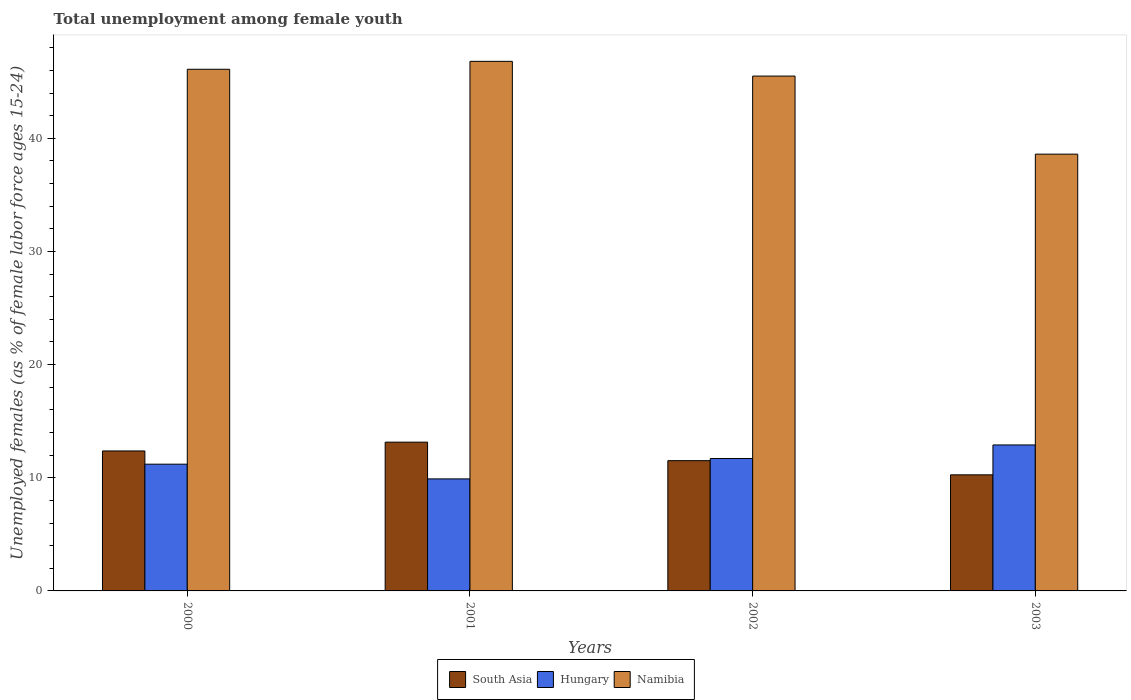How many different coloured bars are there?
Your answer should be compact. 3. How many groups of bars are there?
Keep it short and to the point. 4. Are the number of bars per tick equal to the number of legend labels?
Your response must be concise. Yes. Are the number of bars on each tick of the X-axis equal?
Keep it short and to the point. Yes. How many bars are there on the 4th tick from the left?
Ensure brevity in your answer.  3. How many bars are there on the 3rd tick from the right?
Offer a very short reply. 3. What is the label of the 2nd group of bars from the left?
Offer a very short reply. 2001. What is the percentage of unemployed females in in Hungary in 2002?
Keep it short and to the point. 11.7. Across all years, what is the maximum percentage of unemployed females in in Hungary?
Keep it short and to the point. 12.9. Across all years, what is the minimum percentage of unemployed females in in South Asia?
Your response must be concise. 10.26. What is the total percentage of unemployed females in in Namibia in the graph?
Your answer should be compact. 177. What is the difference between the percentage of unemployed females in in South Asia in 2000 and that in 2003?
Make the answer very short. 2.11. What is the difference between the percentage of unemployed females in in South Asia in 2000 and the percentage of unemployed females in in Namibia in 2002?
Your answer should be compact. -33.13. What is the average percentage of unemployed females in in South Asia per year?
Keep it short and to the point. 11.82. In the year 2001, what is the difference between the percentage of unemployed females in in South Asia and percentage of unemployed females in in Namibia?
Offer a terse response. -33.65. What is the ratio of the percentage of unemployed females in in South Asia in 2000 to that in 2001?
Keep it short and to the point. 0.94. What is the difference between the highest and the second highest percentage of unemployed females in in South Asia?
Provide a succinct answer. 0.78. What is the difference between the highest and the lowest percentage of unemployed females in in South Asia?
Provide a succinct answer. 2.89. Is the sum of the percentage of unemployed females in in Hungary in 2000 and 2002 greater than the maximum percentage of unemployed females in in South Asia across all years?
Keep it short and to the point. Yes. What does the 2nd bar from the left in 2003 represents?
Ensure brevity in your answer.  Hungary. What does the 3rd bar from the right in 2002 represents?
Your answer should be compact. South Asia. Is it the case that in every year, the sum of the percentage of unemployed females in in Hungary and percentage of unemployed females in in Namibia is greater than the percentage of unemployed females in in South Asia?
Make the answer very short. Yes. How many bars are there?
Offer a terse response. 12. Does the graph contain grids?
Keep it short and to the point. No. How many legend labels are there?
Make the answer very short. 3. What is the title of the graph?
Give a very brief answer. Total unemployment among female youth. Does "Nepal" appear as one of the legend labels in the graph?
Provide a succinct answer. No. What is the label or title of the Y-axis?
Keep it short and to the point. Unemployed females (as % of female labor force ages 15-24). What is the Unemployed females (as % of female labor force ages 15-24) in South Asia in 2000?
Your response must be concise. 12.37. What is the Unemployed females (as % of female labor force ages 15-24) of Hungary in 2000?
Provide a succinct answer. 11.2. What is the Unemployed females (as % of female labor force ages 15-24) in Namibia in 2000?
Offer a very short reply. 46.1. What is the Unemployed females (as % of female labor force ages 15-24) in South Asia in 2001?
Your answer should be very brief. 13.15. What is the Unemployed females (as % of female labor force ages 15-24) in Hungary in 2001?
Your answer should be compact. 9.9. What is the Unemployed females (as % of female labor force ages 15-24) of Namibia in 2001?
Your answer should be compact. 46.8. What is the Unemployed females (as % of female labor force ages 15-24) in South Asia in 2002?
Make the answer very short. 11.51. What is the Unemployed females (as % of female labor force ages 15-24) of Hungary in 2002?
Give a very brief answer. 11.7. What is the Unemployed females (as % of female labor force ages 15-24) of Namibia in 2002?
Give a very brief answer. 45.5. What is the Unemployed females (as % of female labor force ages 15-24) in South Asia in 2003?
Your response must be concise. 10.26. What is the Unemployed females (as % of female labor force ages 15-24) of Hungary in 2003?
Your answer should be very brief. 12.9. What is the Unemployed females (as % of female labor force ages 15-24) of Namibia in 2003?
Your response must be concise. 38.6. Across all years, what is the maximum Unemployed females (as % of female labor force ages 15-24) of South Asia?
Your answer should be very brief. 13.15. Across all years, what is the maximum Unemployed females (as % of female labor force ages 15-24) in Hungary?
Your answer should be very brief. 12.9. Across all years, what is the maximum Unemployed females (as % of female labor force ages 15-24) of Namibia?
Provide a short and direct response. 46.8. Across all years, what is the minimum Unemployed females (as % of female labor force ages 15-24) in South Asia?
Your answer should be very brief. 10.26. Across all years, what is the minimum Unemployed females (as % of female labor force ages 15-24) of Hungary?
Provide a short and direct response. 9.9. Across all years, what is the minimum Unemployed females (as % of female labor force ages 15-24) of Namibia?
Keep it short and to the point. 38.6. What is the total Unemployed females (as % of female labor force ages 15-24) in South Asia in the graph?
Your answer should be compact. 47.29. What is the total Unemployed females (as % of female labor force ages 15-24) in Hungary in the graph?
Ensure brevity in your answer.  45.7. What is the total Unemployed females (as % of female labor force ages 15-24) in Namibia in the graph?
Provide a succinct answer. 177. What is the difference between the Unemployed females (as % of female labor force ages 15-24) in South Asia in 2000 and that in 2001?
Your answer should be very brief. -0.78. What is the difference between the Unemployed females (as % of female labor force ages 15-24) in South Asia in 2000 and that in 2002?
Keep it short and to the point. 0.86. What is the difference between the Unemployed females (as % of female labor force ages 15-24) in Hungary in 2000 and that in 2002?
Your answer should be very brief. -0.5. What is the difference between the Unemployed females (as % of female labor force ages 15-24) in Namibia in 2000 and that in 2002?
Your answer should be very brief. 0.6. What is the difference between the Unemployed females (as % of female labor force ages 15-24) in South Asia in 2000 and that in 2003?
Make the answer very short. 2.11. What is the difference between the Unemployed females (as % of female labor force ages 15-24) in Hungary in 2000 and that in 2003?
Offer a very short reply. -1.7. What is the difference between the Unemployed females (as % of female labor force ages 15-24) of South Asia in 2001 and that in 2002?
Make the answer very short. 1.64. What is the difference between the Unemployed females (as % of female labor force ages 15-24) of Hungary in 2001 and that in 2002?
Provide a short and direct response. -1.8. What is the difference between the Unemployed females (as % of female labor force ages 15-24) of South Asia in 2001 and that in 2003?
Ensure brevity in your answer.  2.89. What is the difference between the Unemployed females (as % of female labor force ages 15-24) of South Asia in 2002 and that in 2003?
Offer a very short reply. 1.25. What is the difference between the Unemployed females (as % of female labor force ages 15-24) in Hungary in 2002 and that in 2003?
Offer a very short reply. -1.2. What is the difference between the Unemployed females (as % of female labor force ages 15-24) of Namibia in 2002 and that in 2003?
Offer a very short reply. 6.9. What is the difference between the Unemployed females (as % of female labor force ages 15-24) of South Asia in 2000 and the Unemployed females (as % of female labor force ages 15-24) of Hungary in 2001?
Your answer should be compact. 2.47. What is the difference between the Unemployed females (as % of female labor force ages 15-24) in South Asia in 2000 and the Unemployed females (as % of female labor force ages 15-24) in Namibia in 2001?
Your answer should be compact. -34.43. What is the difference between the Unemployed females (as % of female labor force ages 15-24) in Hungary in 2000 and the Unemployed females (as % of female labor force ages 15-24) in Namibia in 2001?
Give a very brief answer. -35.6. What is the difference between the Unemployed females (as % of female labor force ages 15-24) of South Asia in 2000 and the Unemployed females (as % of female labor force ages 15-24) of Hungary in 2002?
Your answer should be compact. 0.67. What is the difference between the Unemployed females (as % of female labor force ages 15-24) of South Asia in 2000 and the Unemployed females (as % of female labor force ages 15-24) of Namibia in 2002?
Your response must be concise. -33.13. What is the difference between the Unemployed females (as % of female labor force ages 15-24) in Hungary in 2000 and the Unemployed females (as % of female labor force ages 15-24) in Namibia in 2002?
Your answer should be very brief. -34.3. What is the difference between the Unemployed females (as % of female labor force ages 15-24) in South Asia in 2000 and the Unemployed females (as % of female labor force ages 15-24) in Hungary in 2003?
Your answer should be compact. -0.53. What is the difference between the Unemployed females (as % of female labor force ages 15-24) of South Asia in 2000 and the Unemployed females (as % of female labor force ages 15-24) of Namibia in 2003?
Your answer should be very brief. -26.23. What is the difference between the Unemployed females (as % of female labor force ages 15-24) of Hungary in 2000 and the Unemployed females (as % of female labor force ages 15-24) of Namibia in 2003?
Offer a terse response. -27.4. What is the difference between the Unemployed females (as % of female labor force ages 15-24) in South Asia in 2001 and the Unemployed females (as % of female labor force ages 15-24) in Hungary in 2002?
Keep it short and to the point. 1.45. What is the difference between the Unemployed females (as % of female labor force ages 15-24) in South Asia in 2001 and the Unemployed females (as % of female labor force ages 15-24) in Namibia in 2002?
Make the answer very short. -32.35. What is the difference between the Unemployed females (as % of female labor force ages 15-24) in Hungary in 2001 and the Unemployed females (as % of female labor force ages 15-24) in Namibia in 2002?
Provide a short and direct response. -35.6. What is the difference between the Unemployed females (as % of female labor force ages 15-24) of South Asia in 2001 and the Unemployed females (as % of female labor force ages 15-24) of Hungary in 2003?
Your answer should be very brief. 0.25. What is the difference between the Unemployed females (as % of female labor force ages 15-24) of South Asia in 2001 and the Unemployed females (as % of female labor force ages 15-24) of Namibia in 2003?
Offer a very short reply. -25.45. What is the difference between the Unemployed females (as % of female labor force ages 15-24) of Hungary in 2001 and the Unemployed females (as % of female labor force ages 15-24) of Namibia in 2003?
Give a very brief answer. -28.7. What is the difference between the Unemployed females (as % of female labor force ages 15-24) of South Asia in 2002 and the Unemployed females (as % of female labor force ages 15-24) of Hungary in 2003?
Your answer should be compact. -1.39. What is the difference between the Unemployed females (as % of female labor force ages 15-24) in South Asia in 2002 and the Unemployed females (as % of female labor force ages 15-24) in Namibia in 2003?
Give a very brief answer. -27.09. What is the difference between the Unemployed females (as % of female labor force ages 15-24) in Hungary in 2002 and the Unemployed females (as % of female labor force ages 15-24) in Namibia in 2003?
Offer a very short reply. -26.9. What is the average Unemployed females (as % of female labor force ages 15-24) in South Asia per year?
Your answer should be very brief. 11.82. What is the average Unemployed females (as % of female labor force ages 15-24) in Hungary per year?
Make the answer very short. 11.43. What is the average Unemployed females (as % of female labor force ages 15-24) in Namibia per year?
Offer a very short reply. 44.25. In the year 2000, what is the difference between the Unemployed females (as % of female labor force ages 15-24) in South Asia and Unemployed females (as % of female labor force ages 15-24) in Hungary?
Make the answer very short. 1.17. In the year 2000, what is the difference between the Unemployed females (as % of female labor force ages 15-24) in South Asia and Unemployed females (as % of female labor force ages 15-24) in Namibia?
Offer a very short reply. -33.73. In the year 2000, what is the difference between the Unemployed females (as % of female labor force ages 15-24) in Hungary and Unemployed females (as % of female labor force ages 15-24) in Namibia?
Give a very brief answer. -34.9. In the year 2001, what is the difference between the Unemployed females (as % of female labor force ages 15-24) of South Asia and Unemployed females (as % of female labor force ages 15-24) of Hungary?
Ensure brevity in your answer.  3.25. In the year 2001, what is the difference between the Unemployed females (as % of female labor force ages 15-24) of South Asia and Unemployed females (as % of female labor force ages 15-24) of Namibia?
Keep it short and to the point. -33.65. In the year 2001, what is the difference between the Unemployed females (as % of female labor force ages 15-24) of Hungary and Unemployed females (as % of female labor force ages 15-24) of Namibia?
Offer a terse response. -36.9. In the year 2002, what is the difference between the Unemployed females (as % of female labor force ages 15-24) in South Asia and Unemployed females (as % of female labor force ages 15-24) in Hungary?
Ensure brevity in your answer.  -0.19. In the year 2002, what is the difference between the Unemployed females (as % of female labor force ages 15-24) in South Asia and Unemployed females (as % of female labor force ages 15-24) in Namibia?
Ensure brevity in your answer.  -33.99. In the year 2002, what is the difference between the Unemployed females (as % of female labor force ages 15-24) in Hungary and Unemployed females (as % of female labor force ages 15-24) in Namibia?
Keep it short and to the point. -33.8. In the year 2003, what is the difference between the Unemployed females (as % of female labor force ages 15-24) in South Asia and Unemployed females (as % of female labor force ages 15-24) in Hungary?
Give a very brief answer. -2.64. In the year 2003, what is the difference between the Unemployed females (as % of female labor force ages 15-24) of South Asia and Unemployed females (as % of female labor force ages 15-24) of Namibia?
Offer a terse response. -28.34. In the year 2003, what is the difference between the Unemployed females (as % of female labor force ages 15-24) in Hungary and Unemployed females (as % of female labor force ages 15-24) in Namibia?
Provide a succinct answer. -25.7. What is the ratio of the Unemployed females (as % of female labor force ages 15-24) in South Asia in 2000 to that in 2001?
Offer a terse response. 0.94. What is the ratio of the Unemployed females (as % of female labor force ages 15-24) of Hungary in 2000 to that in 2001?
Your answer should be compact. 1.13. What is the ratio of the Unemployed females (as % of female labor force ages 15-24) of South Asia in 2000 to that in 2002?
Make the answer very short. 1.07. What is the ratio of the Unemployed females (as % of female labor force ages 15-24) in Hungary in 2000 to that in 2002?
Make the answer very short. 0.96. What is the ratio of the Unemployed females (as % of female labor force ages 15-24) of Namibia in 2000 to that in 2002?
Ensure brevity in your answer.  1.01. What is the ratio of the Unemployed females (as % of female labor force ages 15-24) of South Asia in 2000 to that in 2003?
Offer a terse response. 1.21. What is the ratio of the Unemployed females (as % of female labor force ages 15-24) of Hungary in 2000 to that in 2003?
Keep it short and to the point. 0.87. What is the ratio of the Unemployed females (as % of female labor force ages 15-24) in Namibia in 2000 to that in 2003?
Keep it short and to the point. 1.19. What is the ratio of the Unemployed females (as % of female labor force ages 15-24) of South Asia in 2001 to that in 2002?
Ensure brevity in your answer.  1.14. What is the ratio of the Unemployed females (as % of female labor force ages 15-24) of Hungary in 2001 to that in 2002?
Provide a short and direct response. 0.85. What is the ratio of the Unemployed females (as % of female labor force ages 15-24) in Namibia in 2001 to that in 2002?
Provide a short and direct response. 1.03. What is the ratio of the Unemployed females (as % of female labor force ages 15-24) of South Asia in 2001 to that in 2003?
Offer a terse response. 1.28. What is the ratio of the Unemployed females (as % of female labor force ages 15-24) of Hungary in 2001 to that in 2003?
Make the answer very short. 0.77. What is the ratio of the Unemployed females (as % of female labor force ages 15-24) in Namibia in 2001 to that in 2003?
Provide a succinct answer. 1.21. What is the ratio of the Unemployed females (as % of female labor force ages 15-24) of South Asia in 2002 to that in 2003?
Your response must be concise. 1.12. What is the ratio of the Unemployed females (as % of female labor force ages 15-24) of Hungary in 2002 to that in 2003?
Keep it short and to the point. 0.91. What is the ratio of the Unemployed females (as % of female labor force ages 15-24) in Namibia in 2002 to that in 2003?
Provide a short and direct response. 1.18. What is the difference between the highest and the second highest Unemployed females (as % of female labor force ages 15-24) in South Asia?
Your answer should be compact. 0.78. What is the difference between the highest and the lowest Unemployed females (as % of female labor force ages 15-24) of South Asia?
Your answer should be compact. 2.89. What is the difference between the highest and the lowest Unemployed females (as % of female labor force ages 15-24) of Hungary?
Provide a short and direct response. 3. What is the difference between the highest and the lowest Unemployed females (as % of female labor force ages 15-24) of Namibia?
Your answer should be very brief. 8.2. 